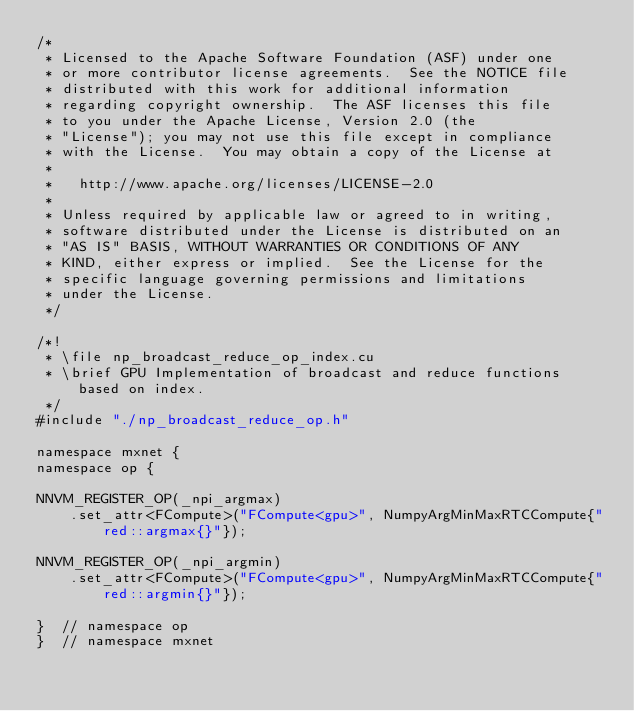Convert code to text. <code><loc_0><loc_0><loc_500><loc_500><_Cuda_>/*
 * Licensed to the Apache Software Foundation (ASF) under one
 * or more contributor license agreements.  See the NOTICE file
 * distributed with this work for additional information
 * regarding copyright ownership.  The ASF licenses this file
 * to you under the Apache License, Version 2.0 (the
 * "License"); you may not use this file except in compliance
 * with the License.  You may obtain a copy of the License at
 *
 *   http://www.apache.org/licenses/LICENSE-2.0
 *
 * Unless required by applicable law or agreed to in writing,
 * software distributed under the License is distributed on an
 * "AS IS" BASIS, WITHOUT WARRANTIES OR CONDITIONS OF ANY
 * KIND, either express or implied.  See the License for the
 * specific language governing permissions and limitations
 * under the License.
 */

/*!
 * \file np_broadcast_reduce_op_index.cu
 * \brief GPU Implementation of broadcast and reduce functions based on index.
 */
#include "./np_broadcast_reduce_op.h"

namespace mxnet {
namespace op {

NNVM_REGISTER_OP(_npi_argmax)
    .set_attr<FCompute>("FCompute<gpu>", NumpyArgMinMaxRTCCompute{"red::argmax{}"});

NNVM_REGISTER_OP(_npi_argmin)
    .set_attr<FCompute>("FCompute<gpu>", NumpyArgMinMaxRTCCompute{"red::argmin{}"});

}  // namespace op
}  // namespace mxnet
</code> 